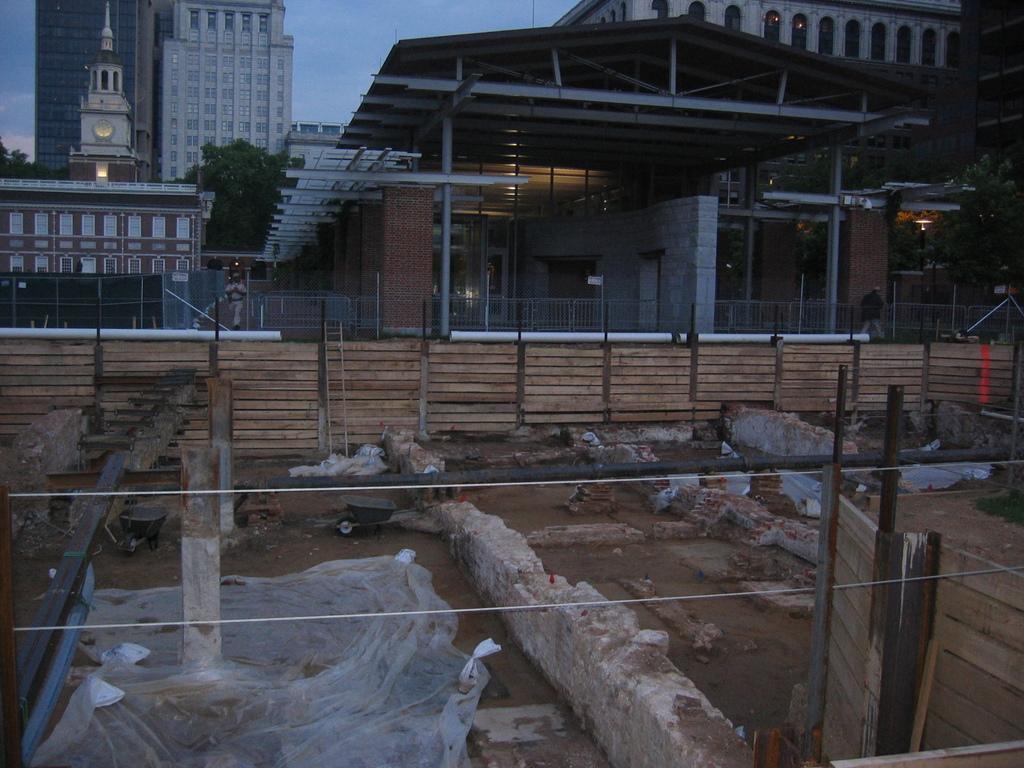Describe this image in one or two sentences. In the background of the image there are buildings. There are trees. There is a fencing. 